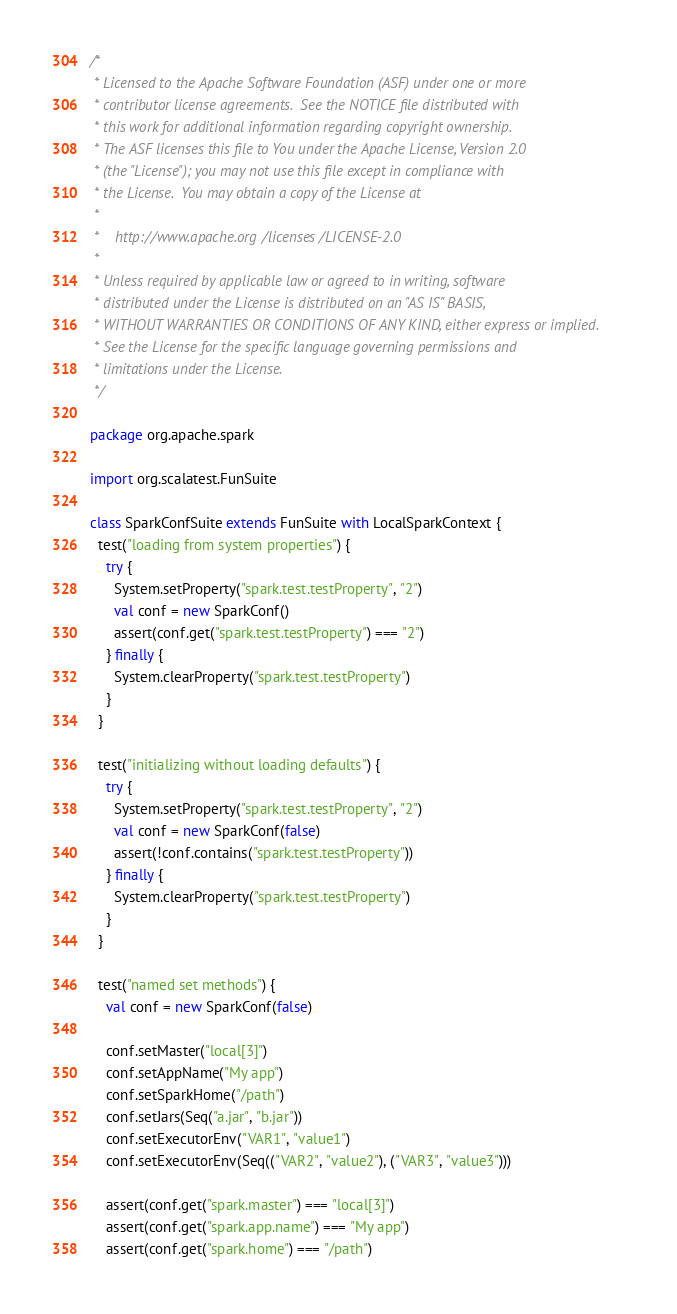Convert code to text. <code><loc_0><loc_0><loc_500><loc_500><_Scala_>/*
 * Licensed to the Apache Software Foundation (ASF) under one or more
 * contributor license agreements.  See the NOTICE file distributed with
 * this work for additional information regarding copyright ownership.
 * The ASF licenses this file to You under the Apache License, Version 2.0
 * (the "License"); you may not use this file except in compliance with
 * the License.  You may obtain a copy of the License at
 *
 *    http://www.apache.org/licenses/LICENSE-2.0
 *
 * Unless required by applicable law or agreed to in writing, software
 * distributed under the License is distributed on an "AS IS" BASIS,
 * WITHOUT WARRANTIES OR CONDITIONS OF ANY KIND, either express or implied.
 * See the License for the specific language governing permissions and
 * limitations under the License.
 */

package org.apache.spark

import org.scalatest.FunSuite

class SparkConfSuite extends FunSuite with LocalSparkContext {
  test("loading from system properties") {
    try {
      System.setProperty("spark.test.testProperty", "2")
      val conf = new SparkConf()
      assert(conf.get("spark.test.testProperty") === "2")
    } finally {
      System.clearProperty("spark.test.testProperty")
    }
  }

  test("initializing without loading defaults") {
    try {
      System.setProperty("spark.test.testProperty", "2")
      val conf = new SparkConf(false)
      assert(!conf.contains("spark.test.testProperty"))
    } finally {
      System.clearProperty("spark.test.testProperty")
    }
  }

  test("named set methods") {
    val conf = new SparkConf(false)

    conf.setMaster("local[3]")
    conf.setAppName("My app")
    conf.setSparkHome("/path")
    conf.setJars(Seq("a.jar", "b.jar"))
    conf.setExecutorEnv("VAR1", "value1")
    conf.setExecutorEnv(Seq(("VAR2", "value2"), ("VAR3", "value3")))

    assert(conf.get("spark.master") === "local[3]")
    assert(conf.get("spark.app.name") === "My app")
    assert(conf.get("spark.home") === "/path")</code> 